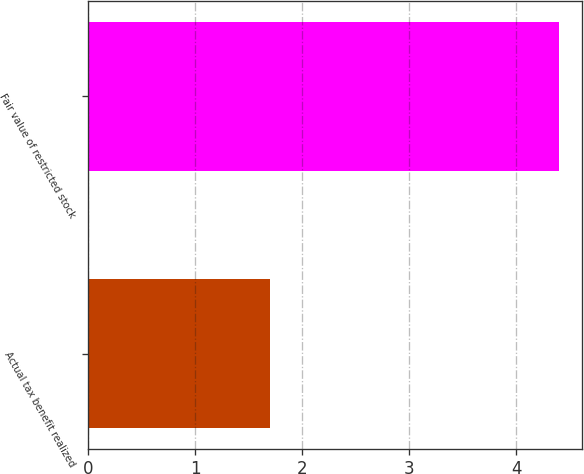<chart> <loc_0><loc_0><loc_500><loc_500><bar_chart><fcel>Actual tax benefit realized<fcel>Fair value of restricted stock<nl><fcel>1.7<fcel>4.4<nl></chart> 